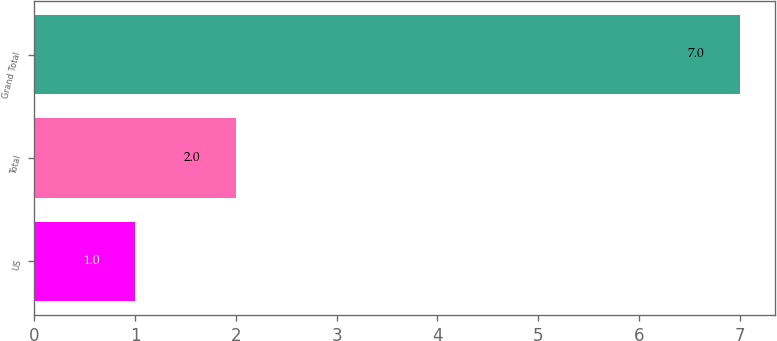Convert chart. <chart><loc_0><loc_0><loc_500><loc_500><bar_chart><fcel>US<fcel>Total<fcel>Grand Total<nl><fcel>1<fcel>2<fcel>7<nl></chart> 